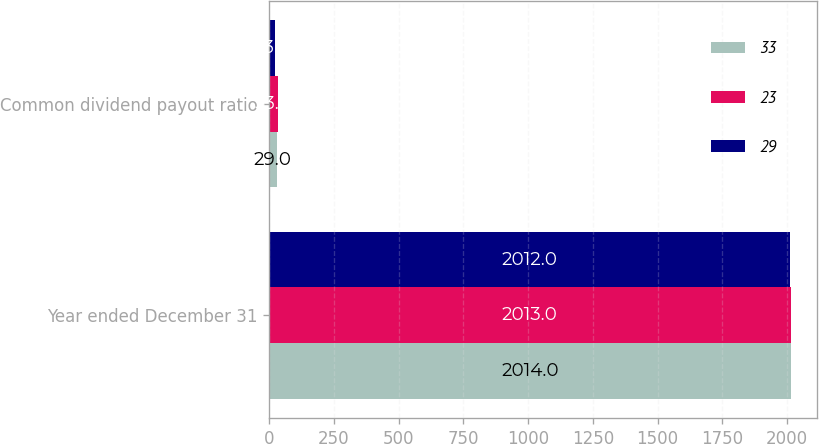Convert chart to OTSL. <chart><loc_0><loc_0><loc_500><loc_500><stacked_bar_chart><ecel><fcel>Year ended December 31<fcel>Common dividend payout ratio<nl><fcel>33<fcel>2014<fcel>29<nl><fcel>23<fcel>2013<fcel>33<nl><fcel>29<fcel>2012<fcel>23<nl></chart> 